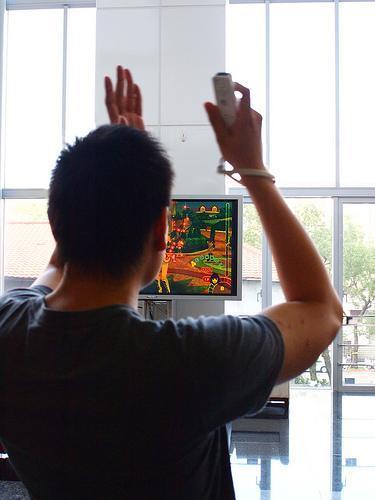How many people are pictured?
Give a very brief answer. 1. 